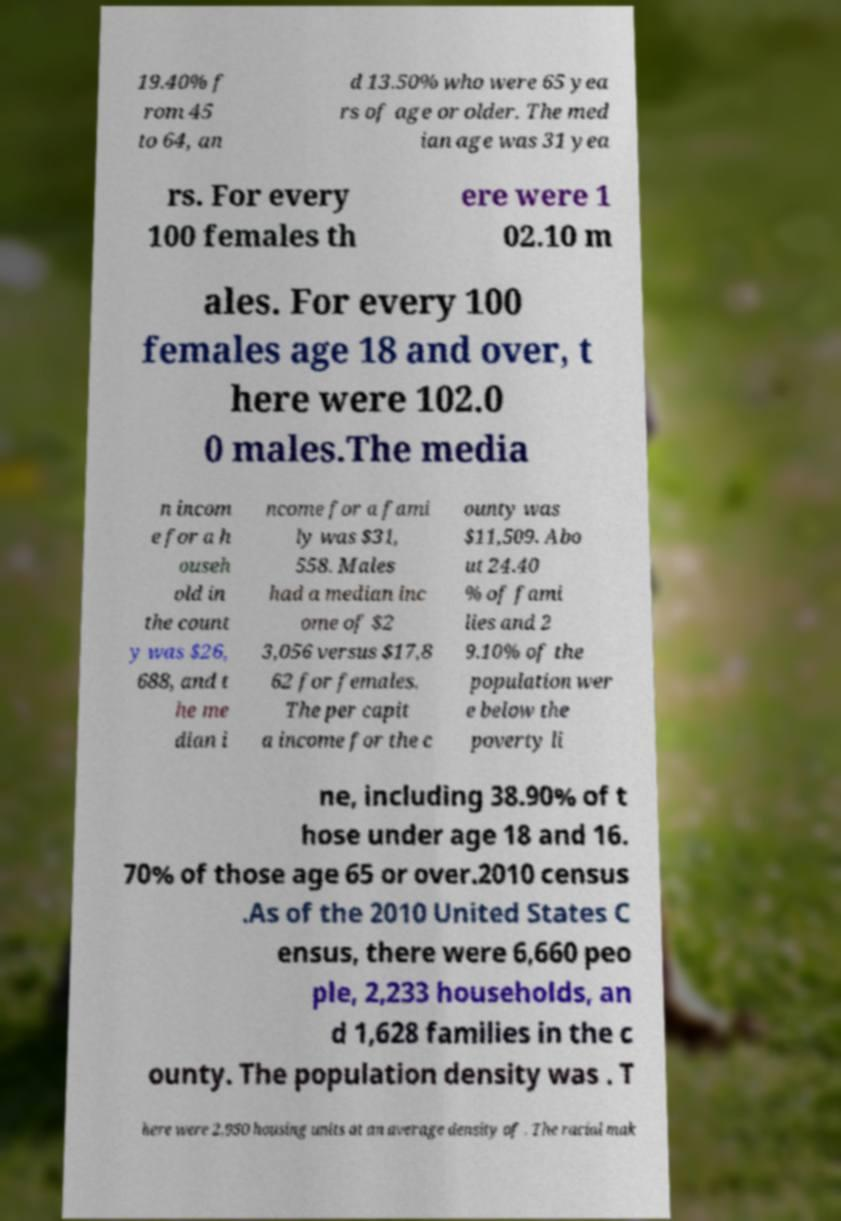Please identify and transcribe the text found in this image. 19.40% f rom 45 to 64, an d 13.50% who were 65 yea rs of age or older. The med ian age was 31 yea rs. For every 100 females th ere were 1 02.10 m ales. For every 100 females age 18 and over, t here were 102.0 0 males.The media n incom e for a h ouseh old in the count y was $26, 688, and t he me dian i ncome for a fami ly was $31, 558. Males had a median inc ome of $2 3,056 versus $17,8 62 for females. The per capit a income for the c ounty was $11,509. Abo ut 24.40 % of fami lies and 2 9.10% of the population wer e below the poverty li ne, including 38.90% of t hose under age 18 and 16. 70% of those age 65 or over.2010 census .As of the 2010 United States C ensus, there were 6,660 peo ple, 2,233 households, an d 1,628 families in the c ounty. The population density was . T here were 2,950 housing units at an average density of . The racial mak 